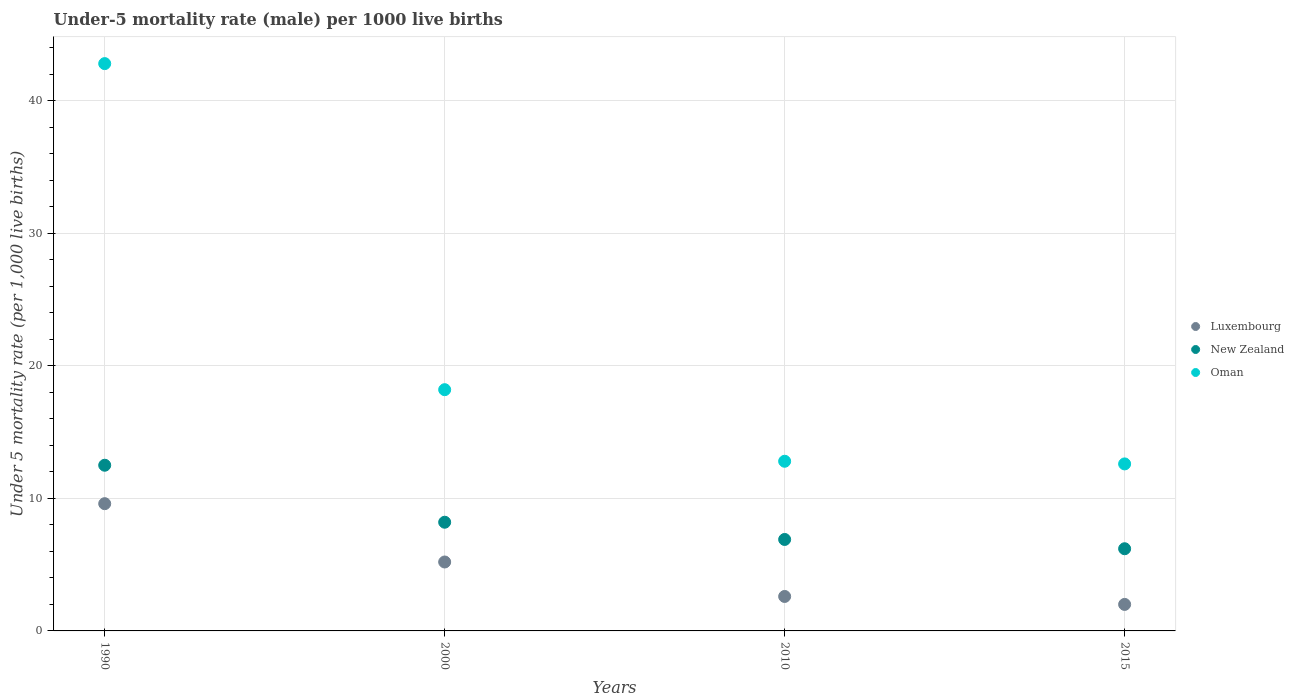How many different coloured dotlines are there?
Provide a succinct answer. 3. Is the number of dotlines equal to the number of legend labels?
Your answer should be compact. Yes. What is the under-five mortality rate in New Zealand in 2015?
Give a very brief answer. 6.2. Across all years, what is the maximum under-five mortality rate in Luxembourg?
Your response must be concise. 9.6. In which year was the under-five mortality rate in Oman maximum?
Ensure brevity in your answer.  1990. In which year was the under-five mortality rate in Oman minimum?
Your answer should be compact. 2015. What is the total under-five mortality rate in Oman in the graph?
Keep it short and to the point. 86.4. What is the difference between the under-five mortality rate in New Zealand in 1990 and that in 2000?
Your response must be concise. 4.3. What is the difference between the under-five mortality rate in Luxembourg in 2015 and the under-five mortality rate in Oman in 2000?
Your answer should be compact. -16.2. What is the average under-five mortality rate in Oman per year?
Offer a terse response. 21.6. In the year 1990, what is the difference between the under-five mortality rate in Oman and under-five mortality rate in Luxembourg?
Make the answer very short. 33.2. What is the ratio of the under-five mortality rate in New Zealand in 2010 to that in 2015?
Your answer should be compact. 1.11. What is the difference between the highest and the second highest under-five mortality rate in New Zealand?
Give a very brief answer. 4.3. What is the difference between the highest and the lowest under-five mortality rate in Oman?
Your answer should be compact. 30.2. Is it the case that in every year, the sum of the under-five mortality rate in Oman and under-five mortality rate in Luxembourg  is greater than the under-five mortality rate in New Zealand?
Your response must be concise. Yes. Does the under-five mortality rate in Oman monotonically increase over the years?
Offer a very short reply. No. Is the under-five mortality rate in New Zealand strictly less than the under-five mortality rate in Oman over the years?
Ensure brevity in your answer.  Yes. What is the difference between two consecutive major ticks on the Y-axis?
Your answer should be compact. 10. Does the graph contain grids?
Your response must be concise. Yes. Where does the legend appear in the graph?
Give a very brief answer. Center right. What is the title of the graph?
Provide a succinct answer. Under-5 mortality rate (male) per 1000 live births. Does "Central African Republic" appear as one of the legend labels in the graph?
Provide a succinct answer. No. What is the label or title of the X-axis?
Your answer should be very brief. Years. What is the label or title of the Y-axis?
Ensure brevity in your answer.  Under 5 mortality rate (per 1,0 live births). What is the Under 5 mortality rate (per 1,000 live births) of Oman in 1990?
Offer a very short reply. 42.8. What is the Under 5 mortality rate (per 1,000 live births) of Luxembourg in 2000?
Your answer should be very brief. 5.2. What is the Under 5 mortality rate (per 1,000 live births) of New Zealand in 2010?
Make the answer very short. 6.9. What is the Under 5 mortality rate (per 1,000 live births) in New Zealand in 2015?
Make the answer very short. 6.2. What is the Under 5 mortality rate (per 1,000 live births) of Oman in 2015?
Ensure brevity in your answer.  12.6. Across all years, what is the maximum Under 5 mortality rate (per 1,000 live births) of Luxembourg?
Offer a terse response. 9.6. Across all years, what is the maximum Under 5 mortality rate (per 1,000 live births) of New Zealand?
Your response must be concise. 12.5. Across all years, what is the maximum Under 5 mortality rate (per 1,000 live births) of Oman?
Give a very brief answer. 42.8. Across all years, what is the minimum Under 5 mortality rate (per 1,000 live births) in Luxembourg?
Ensure brevity in your answer.  2. Across all years, what is the minimum Under 5 mortality rate (per 1,000 live births) of New Zealand?
Your answer should be very brief. 6.2. What is the total Under 5 mortality rate (per 1,000 live births) in New Zealand in the graph?
Your answer should be compact. 33.8. What is the total Under 5 mortality rate (per 1,000 live births) of Oman in the graph?
Ensure brevity in your answer.  86.4. What is the difference between the Under 5 mortality rate (per 1,000 live births) of Luxembourg in 1990 and that in 2000?
Your answer should be very brief. 4.4. What is the difference between the Under 5 mortality rate (per 1,000 live births) of Oman in 1990 and that in 2000?
Offer a very short reply. 24.6. What is the difference between the Under 5 mortality rate (per 1,000 live births) in New Zealand in 1990 and that in 2010?
Offer a terse response. 5.6. What is the difference between the Under 5 mortality rate (per 1,000 live births) of Oman in 1990 and that in 2010?
Your answer should be very brief. 30. What is the difference between the Under 5 mortality rate (per 1,000 live births) in Luxembourg in 1990 and that in 2015?
Give a very brief answer. 7.6. What is the difference between the Under 5 mortality rate (per 1,000 live births) in New Zealand in 1990 and that in 2015?
Offer a very short reply. 6.3. What is the difference between the Under 5 mortality rate (per 1,000 live births) of Oman in 1990 and that in 2015?
Give a very brief answer. 30.2. What is the difference between the Under 5 mortality rate (per 1,000 live births) in Oman in 2000 and that in 2010?
Your answer should be compact. 5.4. What is the difference between the Under 5 mortality rate (per 1,000 live births) of Luxembourg in 2000 and that in 2015?
Ensure brevity in your answer.  3.2. What is the difference between the Under 5 mortality rate (per 1,000 live births) in Oman in 2000 and that in 2015?
Offer a very short reply. 5.6. What is the difference between the Under 5 mortality rate (per 1,000 live births) of New Zealand in 2010 and that in 2015?
Make the answer very short. 0.7. What is the difference between the Under 5 mortality rate (per 1,000 live births) in Luxembourg in 1990 and the Under 5 mortality rate (per 1,000 live births) in Oman in 2000?
Your answer should be very brief. -8.6. What is the difference between the Under 5 mortality rate (per 1,000 live births) of Luxembourg in 1990 and the Under 5 mortality rate (per 1,000 live births) of New Zealand in 2010?
Your answer should be very brief. 2.7. What is the difference between the Under 5 mortality rate (per 1,000 live births) of Luxembourg in 1990 and the Under 5 mortality rate (per 1,000 live births) of New Zealand in 2015?
Your answer should be very brief. 3.4. What is the difference between the Under 5 mortality rate (per 1,000 live births) of Luxembourg in 1990 and the Under 5 mortality rate (per 1,000 live births) of Oman in 2015?
Ensure brevity in your answer.  -3. What is the difference between the Under 5 mortality rate (per 1,000 live births) in New Zealand in 1990 and the Under 5 mortality rate (per 1,000 live births) in Oman in 2015?
Your response must be concise. -0.1. What is the difference between the Under 5 mortality rate (per 1,000 live births) in Luxembourg in 2000 and the Under 5 mortality rate (per 1,000 live births) in New Zealand in 2010?
Offer a terse response. -1.7. What is the difference between the Under 5 mortality rate (per 1,000 live births) of New Zealand in 2000 and the Under 5 mortality rate (per 1,000 live births) of Oman in 2010?
Your answer should be very brief. -4.6. What is the difference between the Under 5 mortality rate (per 1,000 live births) in Luxembourg in 2000 and the Under 5 mortality rate (per 1,000 live births) in New Zealand in 2015?
Offer a very short reply. -1. What is the difference between the Under 5 mortality rate (per 1,000 live births) of Luxembourg in 2010 and the Under 5 mortality rate (per 1,000 live births) of New Zealand in 2015?
Your answer should be very brief. -3.6. What is the difference between the Under 5 mortality rate (per 1,000 live births) of Luxembourg in 2010 and the Under 5 mortality rate (per 1,000 live births) of Oman in 2015?
Keep it short and to the point. -10. What is the average Under 5 mortality rate (per 1,000 live births) in Luxembourg per year?
Your response must be concise. 4.85. What is the average Under 5 mortality rate (per 1,000 live births) in New Zealand per year?
Your response must be concise. 8.45. What is the average Under 5 mortality rate (per 1,000 live births) in Oman per year?
Give a very brief answer. 21.6. In the year 1990, what is the difference between the Under 5 mortality rate (per 1,000 live births) of Luxembourg and Under 5 mortality rate (per 1,000 live births) of Oman?
Your response must be concise. -33.2. In the year 1990, what is the difference between the Under 5 mortality rate (per 1,000 live births) of New Zealand and Under 5 mortality rate (per 1,000 live births) of Oman?
Your response must be concise. -30.3. In the year 2000, what is the difference between the Under 5 mortality rate (per 1,000 live births) of Luxembourg and Under 5 mortality rate (per 1,000 live births) of Oman?
Provide a short and direct response. -13. In the year 2015, what is the difference between the Under 5 mortality rate (per 1,000 live births) in Luxembourg and Under 5 mortality rate (per 1,000 live births) in Oman?
Your response must be concise. -10.6. In the year 2015, what is the difference between the Under 5 mortality rate (per 1,000 live births) of New Zealand and Under 5 mortality rate (per 1,000 live births) of Oman?
Keep it short and to the point. -6.4. What is the ratio of the Under 5 mortality rate (per 1,000 live births) in Luxembourg in 1990 to that in 2000?
Provide a succinct answer. 1.85. What is the ratio of the Under 5 mortality rate (per 1,000 live births) in New Zealand in 1990 to that in 2000?
Make the answer very short. 1.52. What is the ratio of the Under 5 mortality rate (per 1,000 live births) in Oman in 1990 to that in 2000?
Offer a very short reply. 2.35. What is the ratio of the Under 5 mortality rate (per 1,000 live births) in Luxembourg in 1990 to that in 2010?
Provide a short and direct response. 3.69. What is the ratio of the Under 5 mortality rate (per 1,000 live births) of New Zealand in 1990 to that in 2010?
Your response must be concise. 1.81. What is the ratio of the Under 5 mortality rate (per 1,000 live births) of Oman in 1990 to that in 2010?
Provide a succinct answer. 3.34. What is the ratio of the Under 5 mortality rate (per 1,000 live births) in New Zealand in 1990 to that in 2015?
Offer a very short reply. 2.02. What is the ratio of the Under 5 mortality rate (per 1,000 live births) in Oman in 1990 to that in 2015?
Keep it short and to the point. 3.4. What is the ratio of the Under 5 mortality rate (per 1,000 live births) of Luxembourg in 2000 to that in 2010?
Your response must be concise. 2. What is the ratio of the Under 5 mortality rate (per 1,000 live births) of New Zealand in 2000 to that in 2010?
Your response must be concise. 1.19. What is the ratio of the Under 5 mortality rate (per 1,000 live births) of Oman in 2000 to that in 2010?
Offer a terse response. 1.42. What is the ratio of the Under 5 mortality rate (per 1,000 live births) in New Zealand in 2000 to that in 2015?
Provide a short and direct response. 1.32. What is the ratio of the Under 5 mortality rate (per 1,000 live births) in Oman in 2000 to that in 2015?
Your response must be concise. 1.44. What is the ratio of the Under 5 mortality rate (per 1,000 live births) of New Zealand in 2010 to that in 2015?
Your answer should be very brief. 1.11. What is the ratio of the Under 5 mortality rate (per 1,000 live births) in Oman in 2010 to that in 2015?
Keep it short and to the point. 1.02. What is the difference between the highest and the second highest Under 5 mortality rate (per 1,000 live births) of Oman?
Your answer should be very brief. 24.6. What is the difference between the highest and the lowest Under 5 mortality rate (per 1,000 live births) in Luxembourg?
Offer a very short reply. 7.6. What is the difference between the highest and the lowest Under 5 mortality rate (per 1,000 live births) in New Zealand?
Ensure brevity in your answer.  6.3. What is the difference between the highest and the lowest Under 5 mortality rate (per 1,000 live births) in Oman?
Make the answer very short. 30.2. 